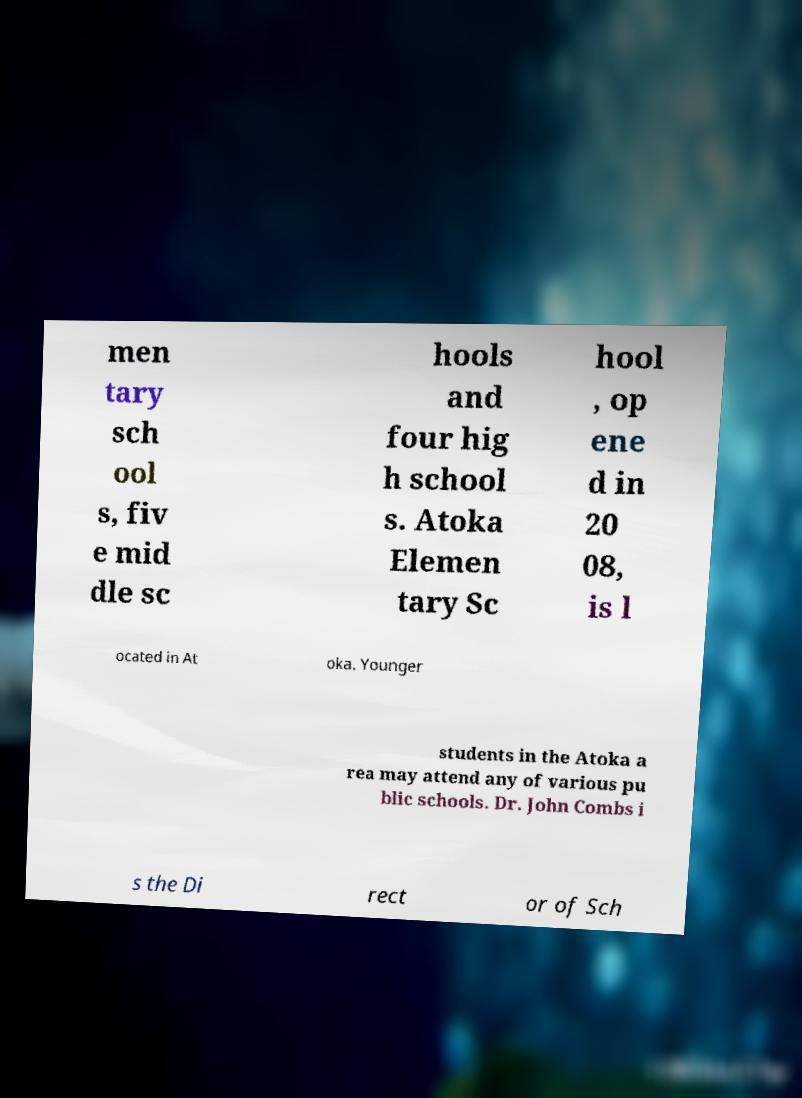Could you assist in decoding the text presented in this image and type it out clearly? men tary sch ool s, fiv e mid dle sc hools and four hig h school s. Atoka Elemen tary Sc hool , op ene d in 20 08, is l ocated in At oka. Younger students in the Atoka a rea may attend any of various pu blic schools. Dr. John Combs i s the Di rect or of Sch 